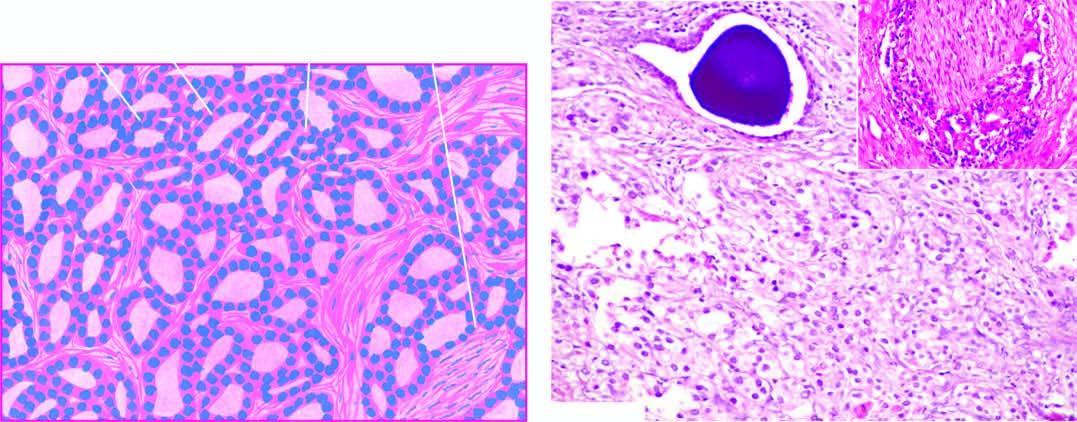does inset in the photomicrograph show perineural invasion by prostatic adenocarcinoma?
Answer the question using a single word or phrase. Yes 